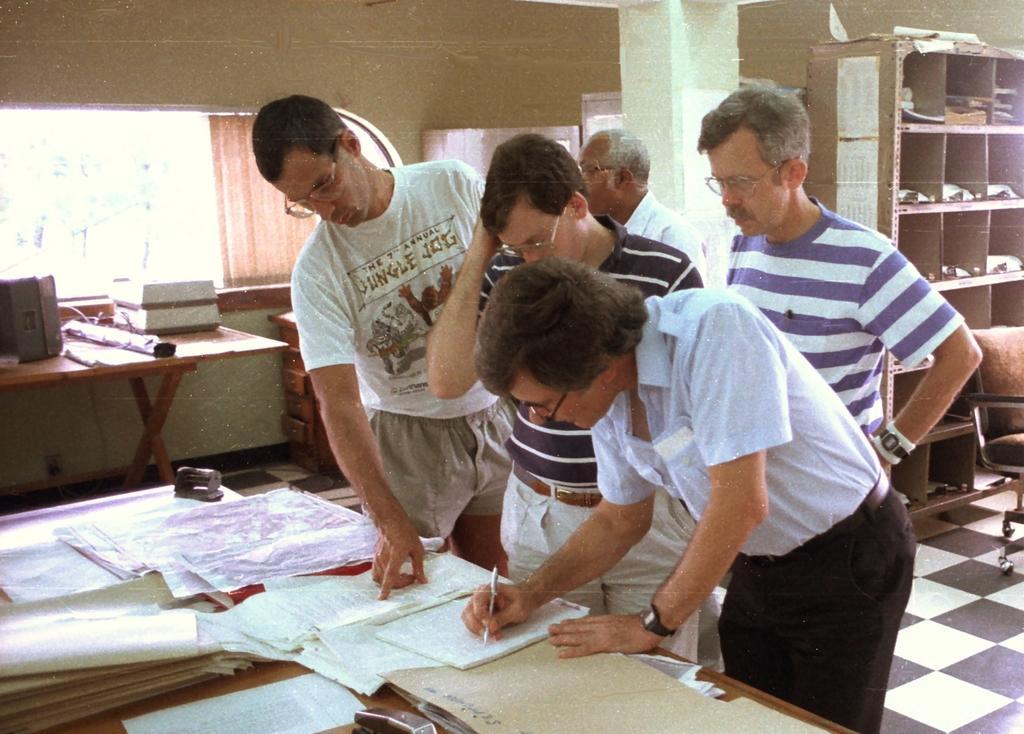In one or two sentences, can you explain what this image depicts? In this image we can see a group of people are standing, and here a person is holding the pen in the hand, and in front here is the table and books and papers on it, and here is the pillar, and here is the wall and here is the books rack. 